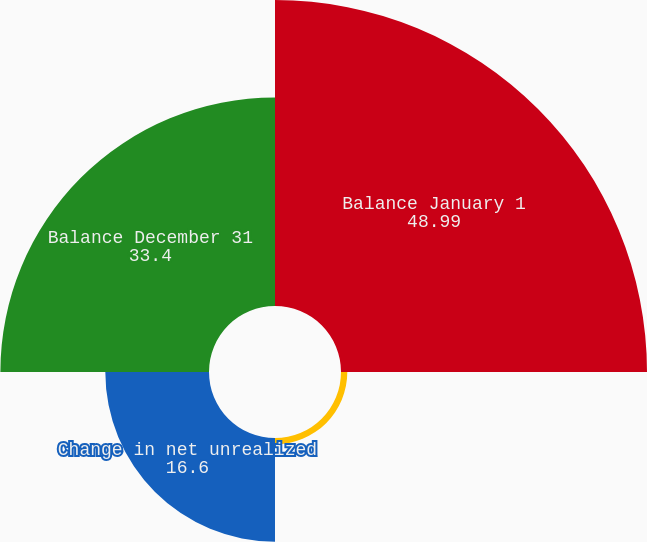Convert chart to OTSL. <chart><loc_0><loc_0><loc_500><loc_500><pie_chart><fcel>Balance January 1<fcel>Impact from earnings allocable<fcel>Change in net unrealized<fcel>Balance December 31<nl><fcel>48.99%<fcel>1.01%<fcel>16.6%<fcel>33.4%<nl></chart> 